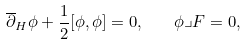<formula> <loc_0><loc_0><loc_500><loc_500>\overline { \partial } _ { H } \phi + \frac { 1 } { 2 } [ \phi , \phi ] = 0 , \quad \phi \lrcorner F = 0 ,</formula> 